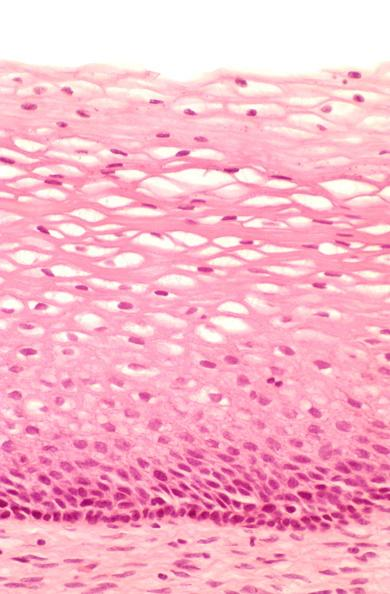s optic nerve present?
Answer the question using a single word or phrase. No 